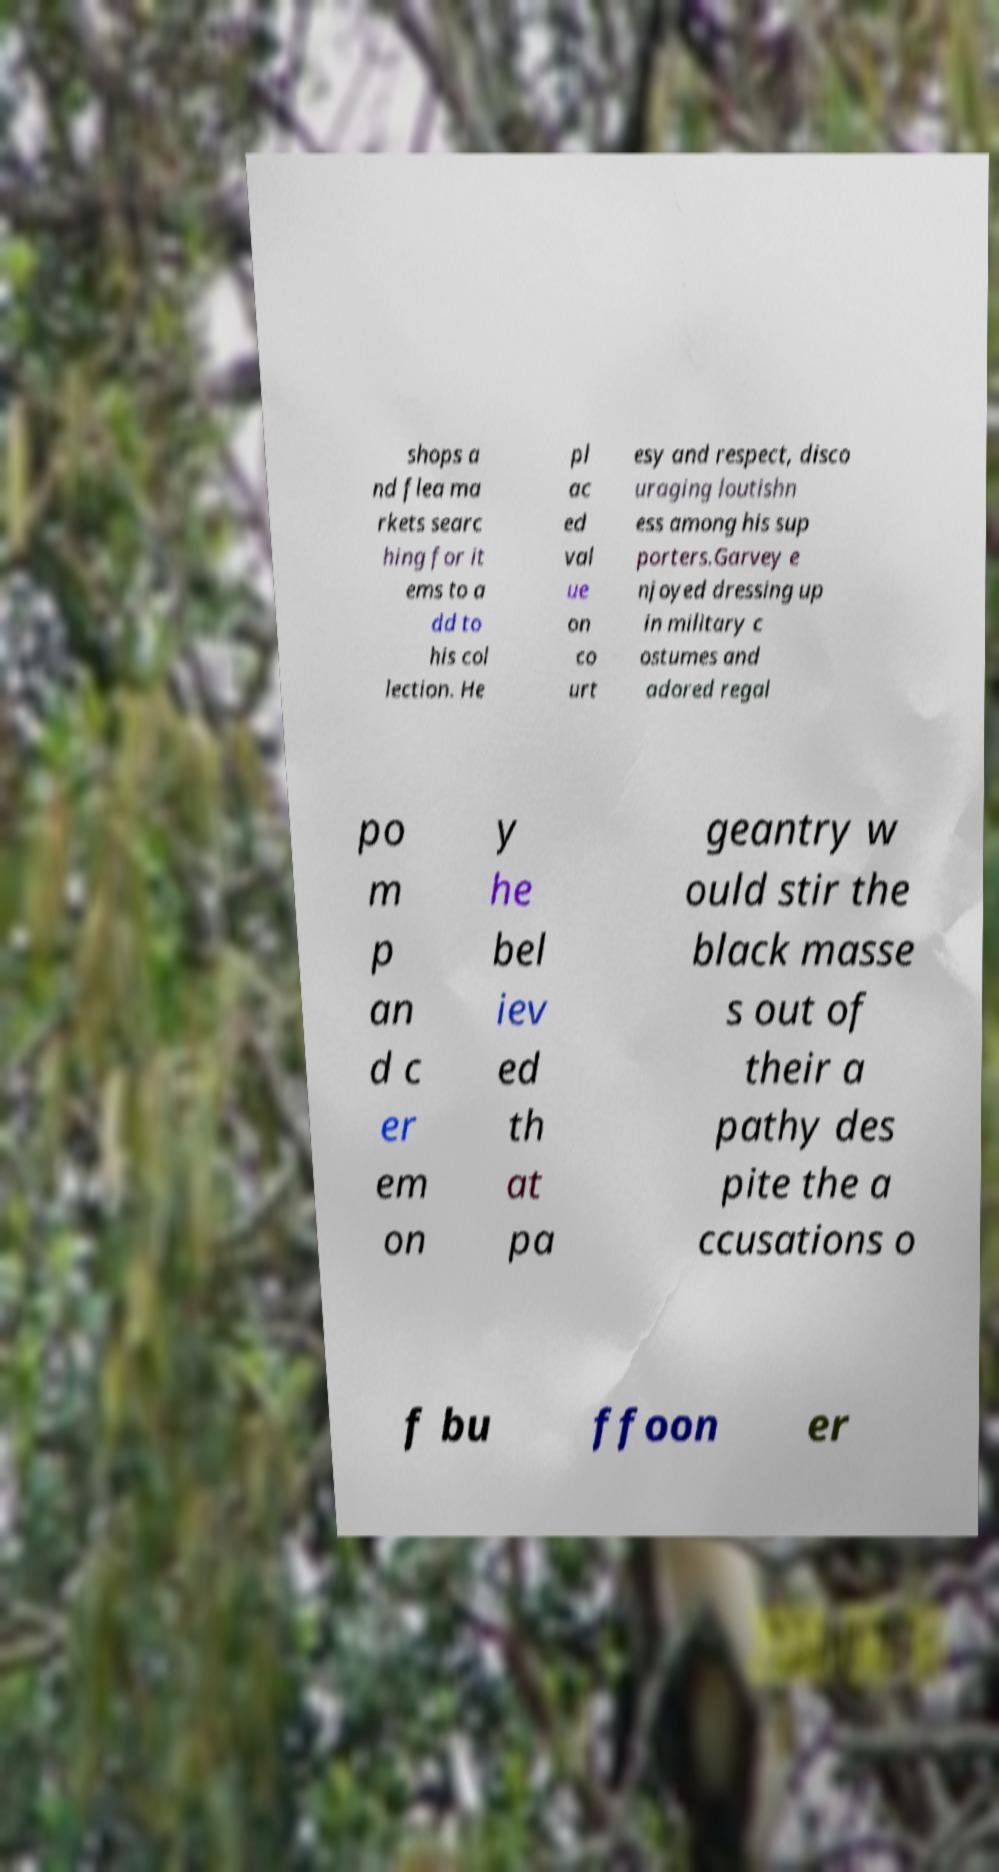Please read and relay the text visible in this image. What does it say? shops a nd flea ma rkets searc hing for it ems to a dd to his col lection. He pl ac ed val ue on co urt esy and respect, disco uraging loutishn ess among his sup porters.Garvey e njoyed dressing up in military c ostumes and adored regal po m p an d c er em on y he bel iev ed th at pa geantry w ould stir the black masse s out of their a pathy des pite the a ccusations o f bu ffoon er 